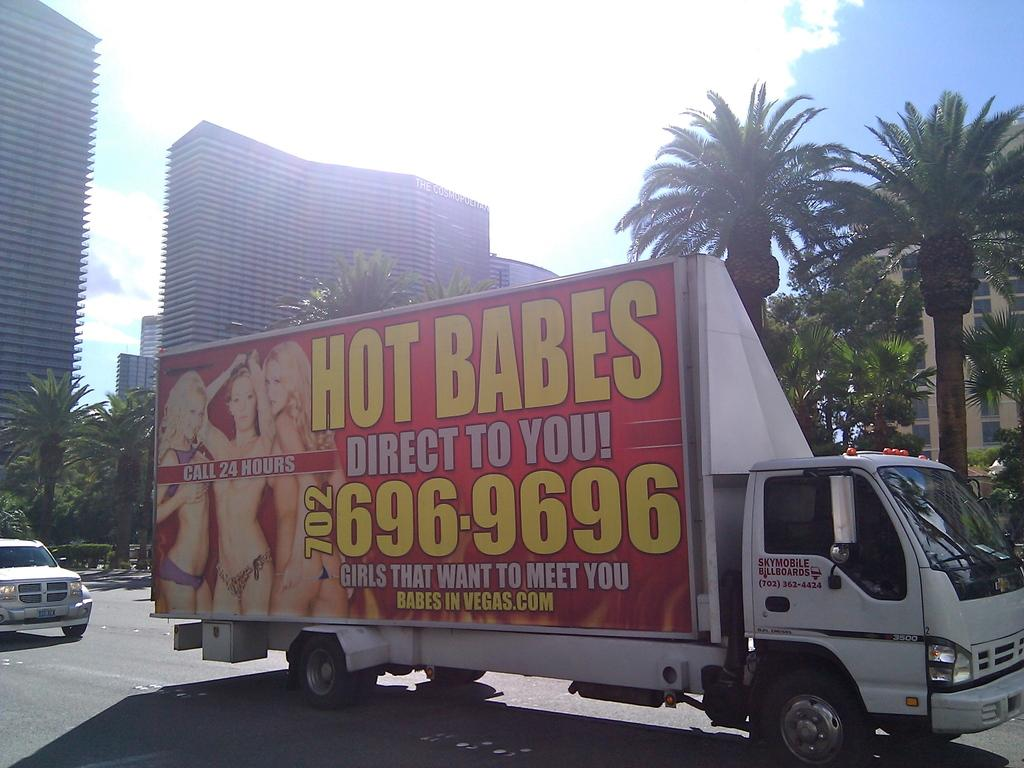What is the main subject in the center of the image? There is a truck in the center of the image. What type of natural elements can be seen in the image? There are many trees in the image. What type of man-made structures are present in the image? There are buildings in the image. What is visible at the top of the image? The sky is visible at the top of the image. What type of surface can be seen at the bottom of the image? There is a road visible at the bottom of the image. Can you see a river flowing through the image? There is no river visible in the image. What type of fear is depicted in the image? There is no fear depicted in the image; it is a scene featuring a truck, trees, buildings, the sky, and a road. 